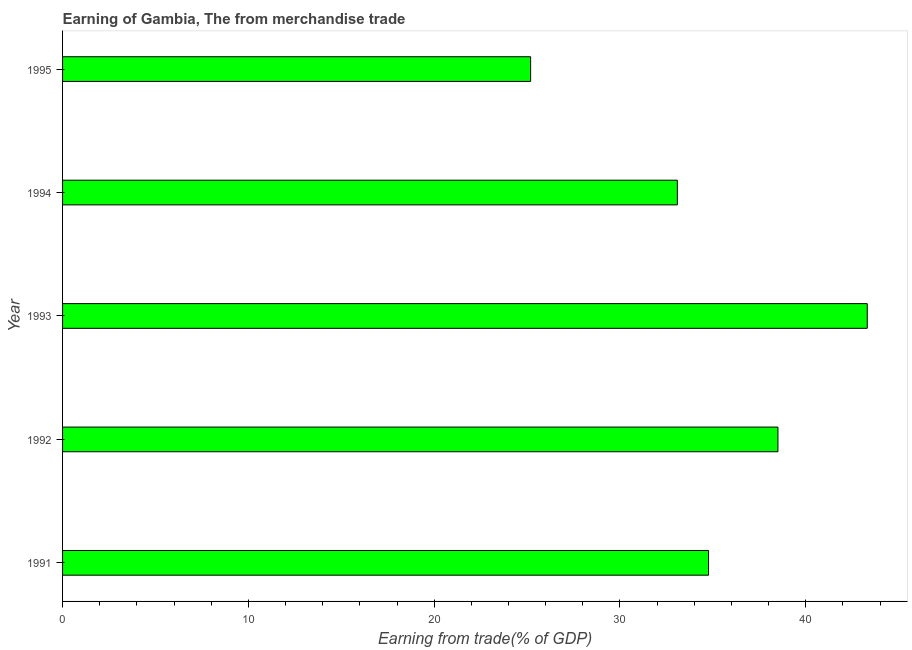Does the graph contain grids?
Your answer should be compact. No. What is the title of the graph?
Your answer should be very brief. Earning of Gambia, The from merchandise trade. What is the label or title of the X-axis?
Keep it short and to the point. Earning from trade(% of GDP). What is the earning from merchandise trade in 1993?
Provide a succinct answer. 43.31. Across all years, what is the maximum earning from merchandise trade?
Provide a succinct answer. 43.31. Across all years, what is the minimum earning from merchandise trade?
Provide a succinct answer. 25.19. What is the sum of the earning from merchandise trade?
Keep it short and to the point. 174.86. What is the difference between the earning from merchandise trade in 1993 and 1994?
Make the answer very short. 10.22. What is the average earning from merchandise trade per year?
Offer a very short reply. 34.97. What is the median earning from merchandise trade?
Keep it short and to the point. 34.77. Do a majority of the years between 1991 and 1995 (inclusive) have earning from merchandise trade greater than 28 %?
Make the answer very short. Yes. What is the ratio of the earning from merchandise trade in 1992 to that in 1993?
Make the answer very short. 0.89. What is the difference between the highest and the second highest earning from merchandise trade?
Provide a short and direct response. 4.81. What is the difference between the highest and the lowest earning from merchandise trade?
Provide a short and direct response. 18.12. In how many years, is the earning from merchandise trade greater than the average earning from merchandise trade taken over all years?
Offer a terse response. 2. How many bars are there?
Your answer should be compact. 5. Are all the bars in the graph horizontal?
Offer a terse response. Yes. How many years are there in the graph?
Make the answer very short. 5. Are the values on the major ticks of X-axis written in scientific E-notation?
Provide a short and direct response. No. What is the Earning from trade(% of GDP) of 1991?
Provide a short and direct response. 34.77. What is the Earning from trade(% of GDP) in 1992?
Your response must be concise. 38.5. What is the Earning from trade(% of GDP) of 1993?
Your answer should be compact. 43.31. What is the Earning from trade(% of GDP) in 1994?
Keep it short and to the point. 33.09. What is the Earning from trade(% of GDP) of 1995?
Your answer should be compact. 25.19. What is the difference between the Earning from trade(% of GDP) in 1991 and 1992?
Offer a terse response. -3.73. What is the difference between the Earning from trade(% of GDP) in 1991 and 1993?
Your answer should be compact. -8.54. What is the difference between the Earning from trade(% of GDP) in 1991 and 1994?
Give a very brief answer. 1.68. What is the difference between the Earning from trade(% of GDP) in 1991 and 1995?
Provide a succinct answer. 9.58. What is the difference between the Earning from trade(% of GDP) in 1992 and 1993?
Provide a short and direct response. -4.81. What is the difference between the Earning from trade(% of GDP) in 1992 and 1994?
Provide a succinct answer. 5.41. What is the difference between the Earning from trade(% of GDP) in 1992 and 1995?
Your response must be concise. 13.31. What is the difference between the Earning from trade(% of GDP) in 1993 and 1994?
Offer a terse response. 10.22. What is the difference between the Earning from trade(% of GDP) in 1993 and 1995?
Give a very brief answer. 18.12. What is the difference between the Earning from trade(% of GDP) in 1994 and 1995?
Your answer should be compact. 7.9. What is the ratio of the Earning from trade(% of GDP) in 1991 to that in 1992?
Your response must be concise. 0.9. What is the ratio of the Earning from trade(% of GDP) in 1991 to that in 1993?
Ensure brevity in your answer.  0.8. What is the ratio of the Earning from trade(% of GDP) in 1991 to that in 1994?
Make the answer very short. 1.05. What is the ratio of the Earning from trade(% of GDP) in 1991 to that in 1995?
Your answer should be very brief. 1.38. What is the ratio of the Earning from trade(% of GDP) in 1992 to that in 1993?
Your response must be concise. 0.89. What is the ratio of the Earning from trade(% of GDP) in 1992 to that in 1994?
Your answer should be very brief. 1.16. What is the ratio of the Earning from trade(% of GDP) in 1992 to that in 1995?
Keep it short and to the point. 1.53. What is the ratio of the Earning from trade(% of GDP) in 1993 to that in 1994?
Provide a short and direct response. 1.31. What is the ratio of the Earning from trade(% of GDP) in 1993 to that in 1995?
Offer a very short reply. 1.72. What is the ratio of the Earning from trade(% of GDP) in 1994 to that in 1995?
Make the answer very short. 1.31. 